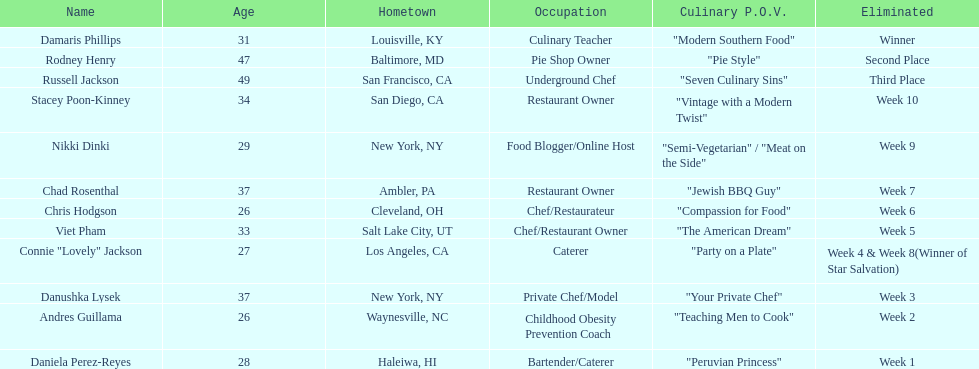Who was the first contestant to be eliminated on season 9 of food network star? Daniela Perez-Reyes. 